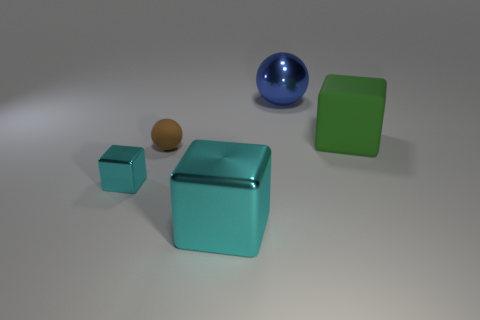Add 4 green matte cylinders. How many objects exist? 9 Subtract 2 blocks. How many blocks are left? 1 Subtract all large rubber cubes. How many cubes are left? 2 Subtract all cubes. How many objects are left? 2 Subtract all blue balls. How many balls are left? 1 Add 4 metal objects. How many metal objects are left? 7 Add 2 tiny objects. How many tiny objects exist? 4 Subtract 0 purple blocks. How many objects are left? 5 Subtract all gray cubes. Subtract all blue cylinders. How many cubes are left? 3 Subtract all red cubes. How many blue spheres are left? 1 